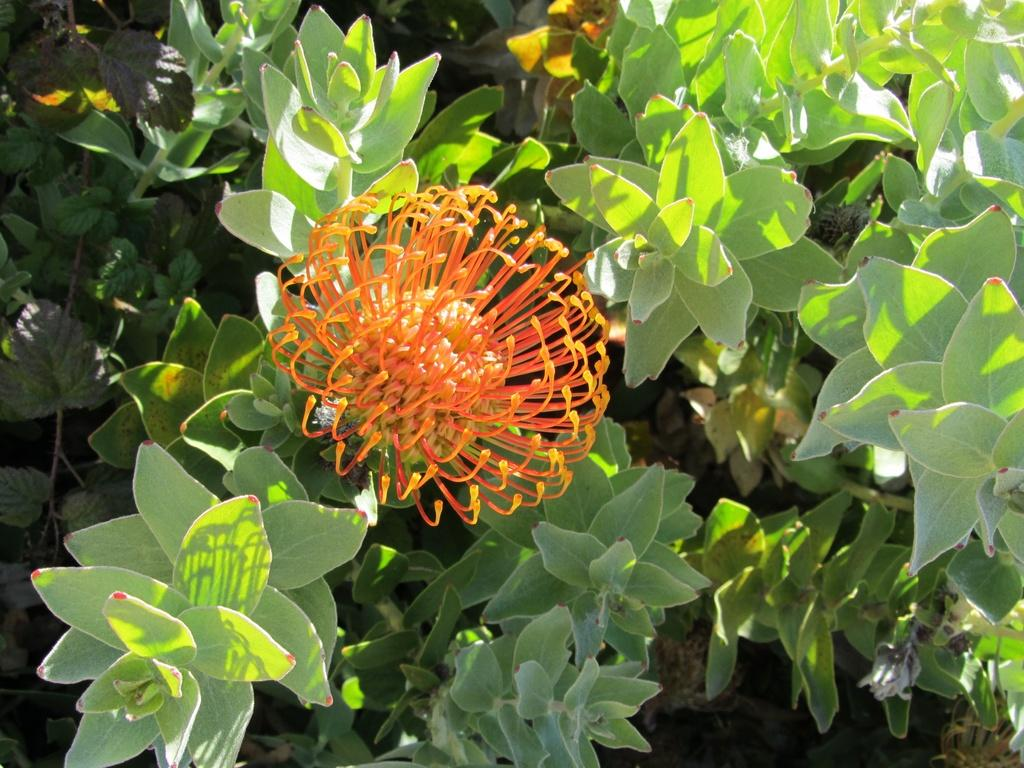What is present in the image? There is a plant in the image. What distinguishing feature does the plant have? The plant has a yellow flower. How does the yellow flower stand out? The yellow flower is unique and different. What type of tank is visible in the image? There is no tank present in the image; it features a plant with a yellow flower. What type of polish is being used on the plant in the image? There is no polish being used on the plant in the image; it is a natural plant with a yellow flower. 